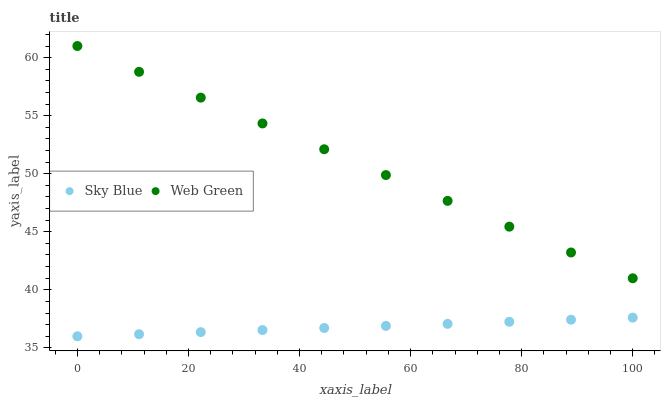Does Sky Blue have the minimum area under the curve?
Answer yes or no. Yes. Does Web Green have the maximum area under the curve?
Answer yes or no. Yes. Does Web Green have the minimum area under the curve?
Answer yes or no. No. Is Web Green the smoothest?
Answer yes or no. Yes. Is Sky Blue the roughest?
Answer yes or no. Yes. Is Web Green the roughest?
Answer yes or no. No. Does Sky Blue have the lowest value?
Answer yes or no. Yes. Does Web Green have the lowest value?
Answer yes or no. No. Does Web Green have the highest value?
Answer yes or no. Yes. Is Sky Blue less than Web Green?
Answer yes or no. Yes. Is Web Green greater than Sky Blue?
Answer yes or no. Yes. Does Sky Blue intersect Web Green?
Answer yes or no. No. 